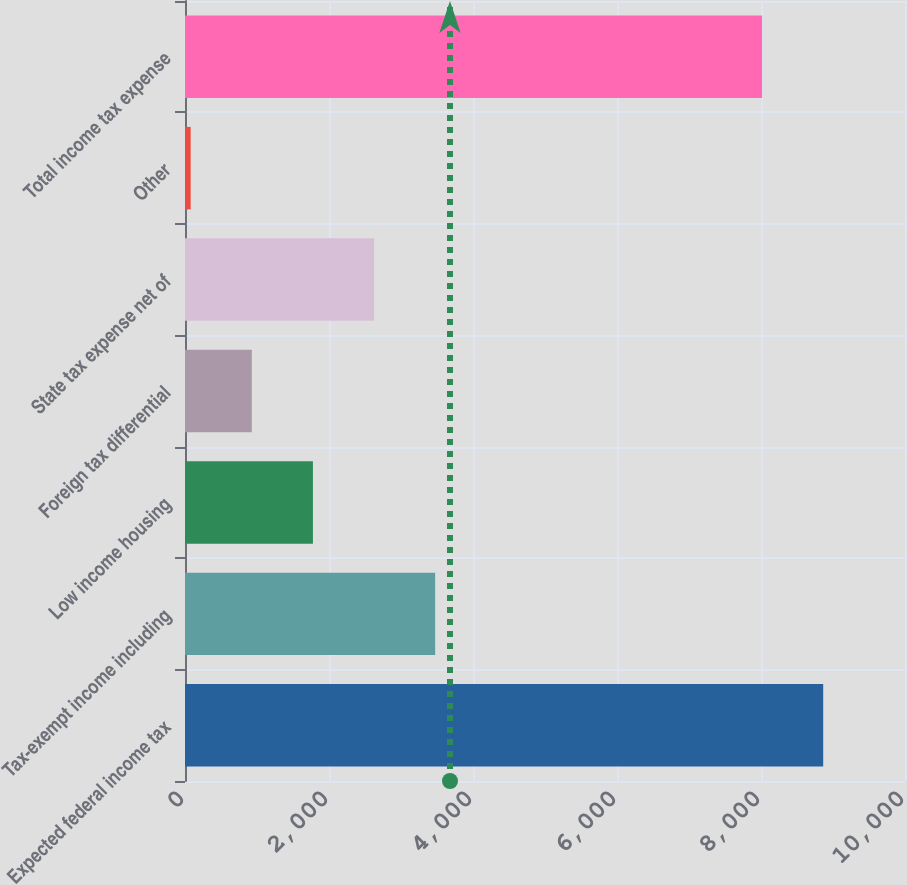Convert chart. <chart><loc_0><loc_0><loc_500><loc_500><bar_chart><fcel>Expected federal income tax<fcel>Tax-exempt income including<fcel>Low income housing<fcel>Foreign tax differential<fcel>State tax expense net of<fcel>Other<fcel>Total income tax expense<nl><fcel>8863.9<fcel>3474.6<fcel>1776.8<fcel>927.9<fcel>2625.7<fcel>79<fcel>8015<nl></chart> 